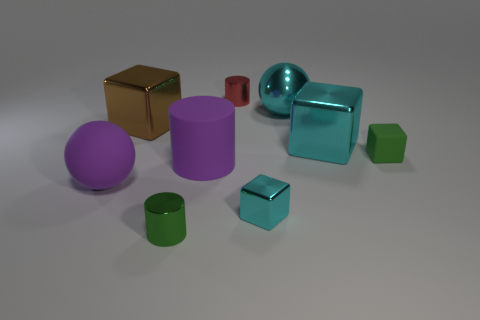Subtract 1 cubes. How many cubes are left? 3 Add 1 small gray matte blocks. How many objects exist? 10 Subtract all spheres. How many objects are left? 7 Subtract 1 red cylinders. How many objects are left? 8 Subtract all tiny red matte cubes. Subtract all tiny green cylinders. How many objects are left? 8 Add 4 large cyan spheres. How many large cyan spheres are left? 5 Add 3 small cyan matte things. How many small cyan matte things exist? 3 